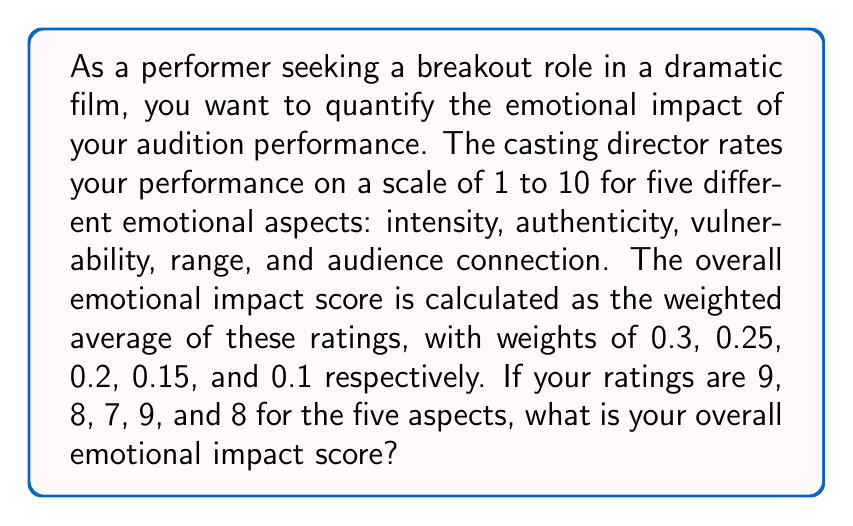Teach me how to tackle this problem. To solve this problem, we need to calculate the weighted average of the ratings. Let's break it down step by step:

1. Identify the ratings and their corresponding weights:
   - Intensity: 9 (weight: 0.3)
   - Authenticity: 8 (weight: 0.25)
   - Vulnerability: 7 (weight: 0.2)
   - Range: 9 (weight: 0.15)
   - Audience connection: 8 (weight: 0.1)

2. Calculate the weighted sum by multiplying each rating by its weight and adding the results:
   $$(9 \times 0.3) + (8 \times 0.25) + (7 \times 0.2) + (9 \times 0.15) + (8 \times 0.1)$$

3. Simplify the calculation:
   $$2.7 + 2.0 + 1.4 + 1.35 + 0.8$$

4. Sum up the weighted values:
   $$2.7 + 2.0 + 1.4 + 1.35 + 0.8 = 8.25$$

Therefore, the overall emotional impact score is 8.25 out of 10.
Answer: 8.25 